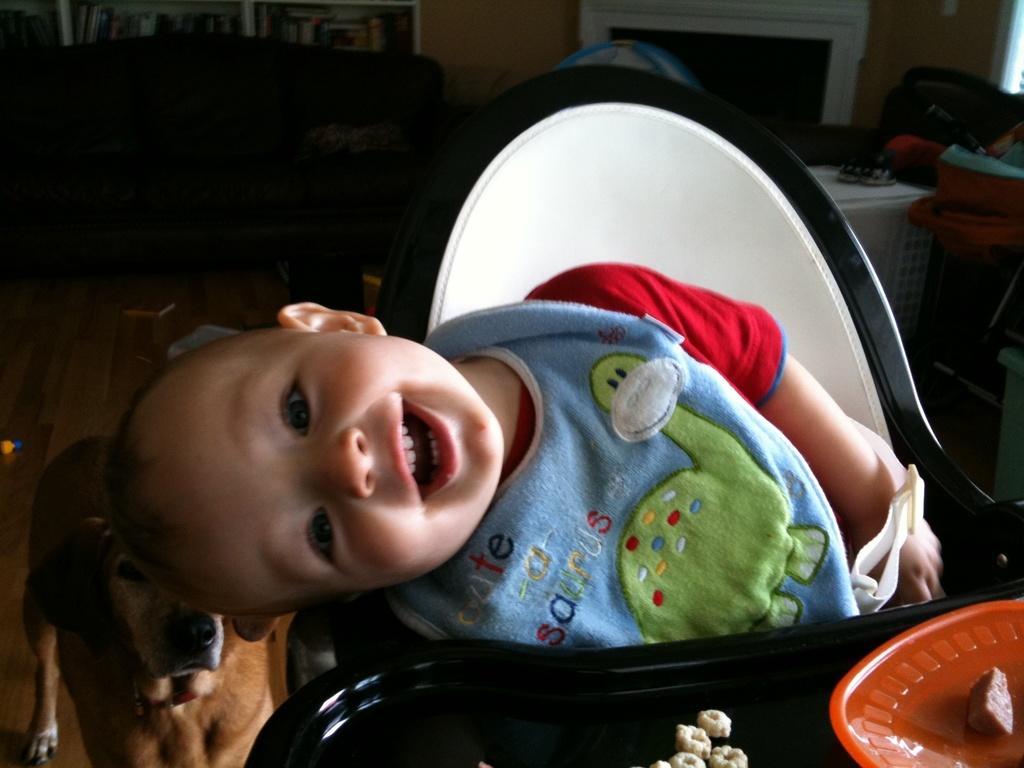Could you give a brief overview of what you see in this image? In the image,there is a baby he is sitting in front of a table and he is smiling and behind him there is a dog,there are some cookies kept in front of the boy and in the background there is a cupboard,a wall and some other objects. 